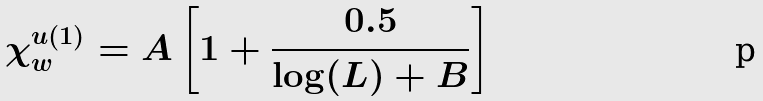Convert formula to latex. <formula><loc_0><loc_0><loc_500><loc_500>\chi _ { w } ^ { u ( 1 ) } = A \left [ 1 + \frac { 0 . 5 } { \log ( L ) + B } \right ]</formula> 